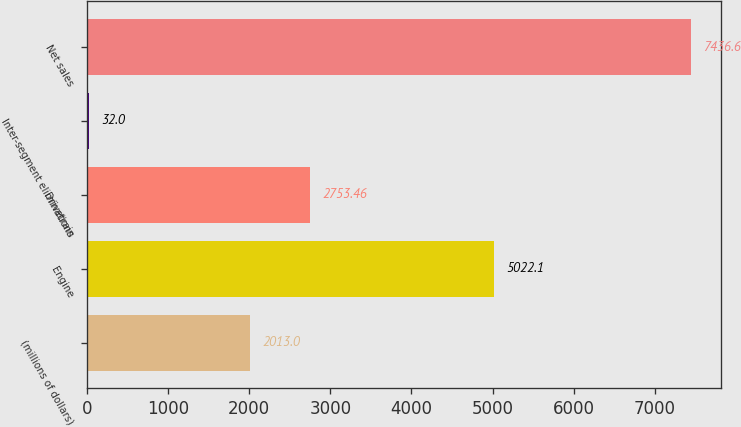Convert chart. <chart><loc_0><loc_0><loc_500><loc_500><bar_chart><fcel>(millions of dollars)<fcel>Engine<fcel>Drivetrain<fcel>Inter-segment eliminations<fcel>Net sales<nl><fcel>2013<fcel>5022.1<fcel>2753.46<fcel>32<fcel>7436.6<nl></chart> 